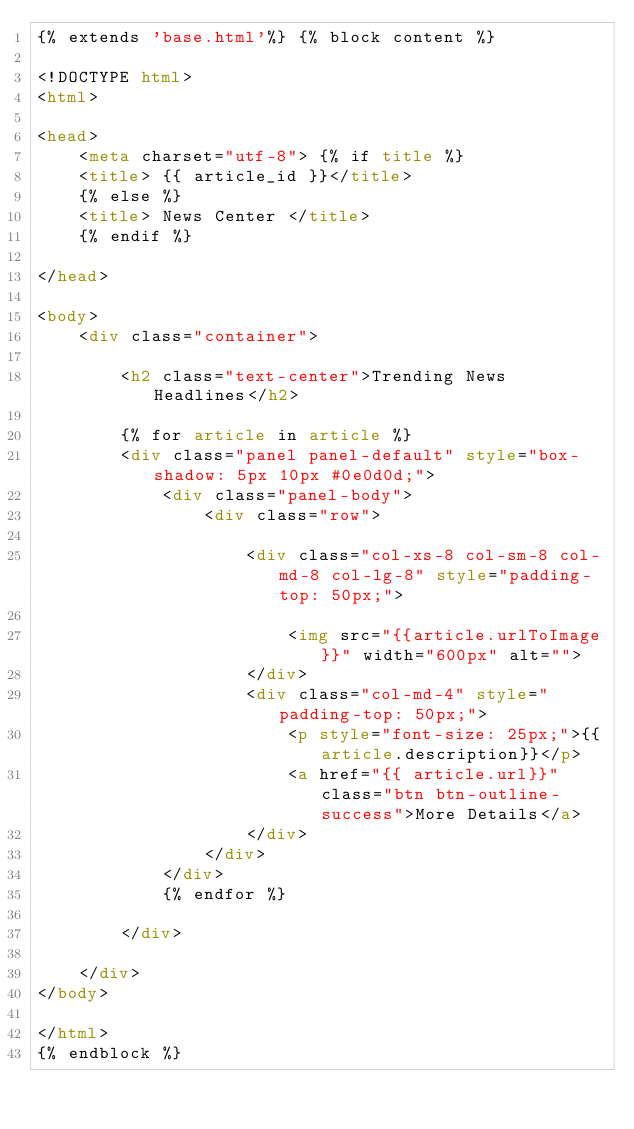Convert code to text. <code><loc_0><loc_0><loc_500><loc_500><_HTML_>{% extends 'base.html'%} {% block content %}

<!DOCTYPE html>
<html>

<head>
    <meta charset="utf-8"> {% if title %}
    <title> {{ article_id }}</title>
    {% else %}
    <title> News Center </title>
    {% endif %}

</head>

<body>
    <div class="container">

        <h2 class="text-center">Trending News Headlines</h2>

        {% for article in article %}
        <div class="panel panel-default" style="box-shadow: 5px 10px #0e0d0d;">
            <div class="panel-body">
                <div class="row">

                    <div class="col-xs-8 col-sm-8 col-md-8 col-lg-8" style="padding-top: 50px;">

                        <img src="{{article.urlToImage}}" width="600px" alt="">
                    </div>
                    <div class="col-md-4" style="padding-top: 50px;">
                        <p style="font-size: 25px;">{{article.description}}</p>
                        <a href="{{ article.url}}" class="btn btn-outline-success">More Details</a>
                    </div>
                </div>
            </div>
            {% endfor %}

        </div>

    </div>
</body>

</html>
{% endblock %}</code> 